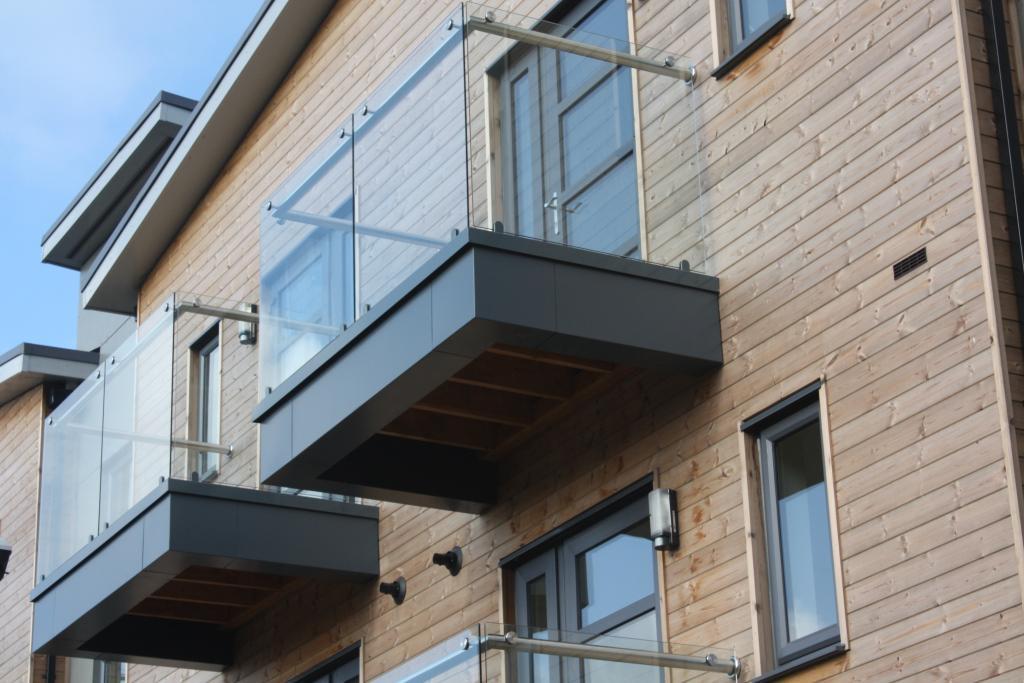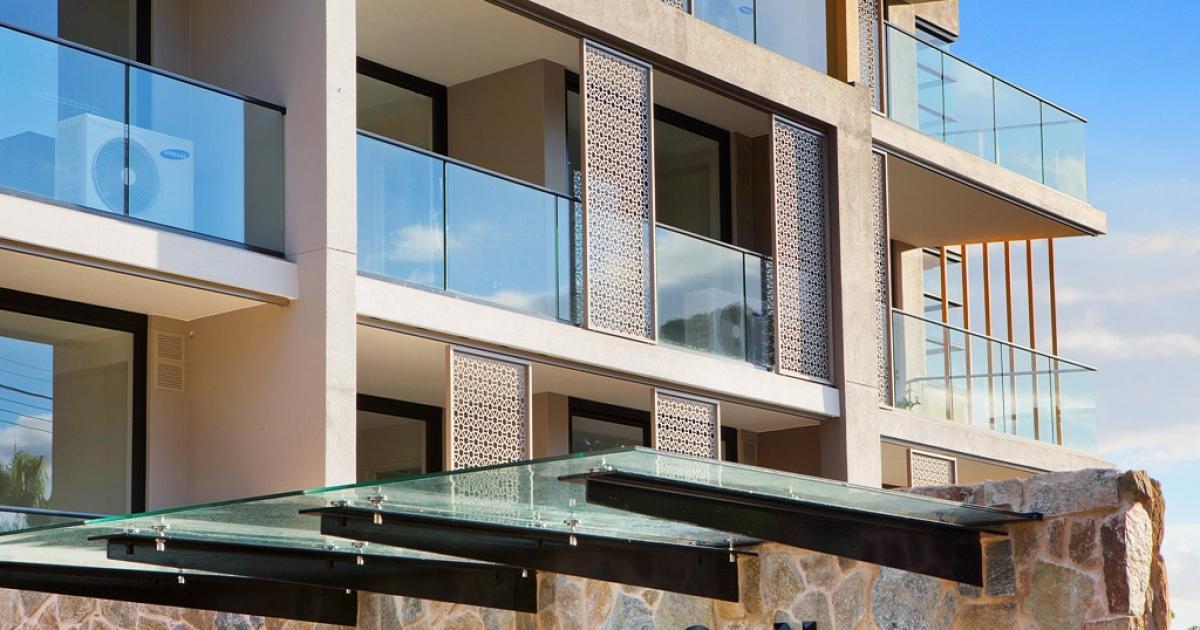The first image is the image on the left, the second image is the image on the right. Evaluate the accuracy of this statement regarding the images: "The left image is an upward view of a white-framed balcony with glass panels instead of rails in front of paned glass windows.". Is it true? Answer yes or no. No. 